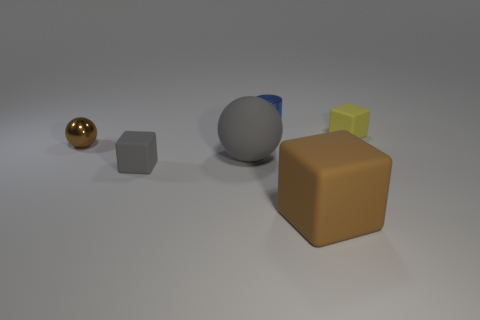Add 2 large brown rubber blocks. How many objects exist? 8 Subtract all cylinders. How many objects are left? 5 Add 1 big purple things. How many big purple things exist? 1 Subtract 0 red cylinders. How many objects are left? 6 Subtract all shiny balls. Subtract all yellow rubber blocks. How many objects are left? 4 Add 4 rubber things. How many rubber things are left? 8 